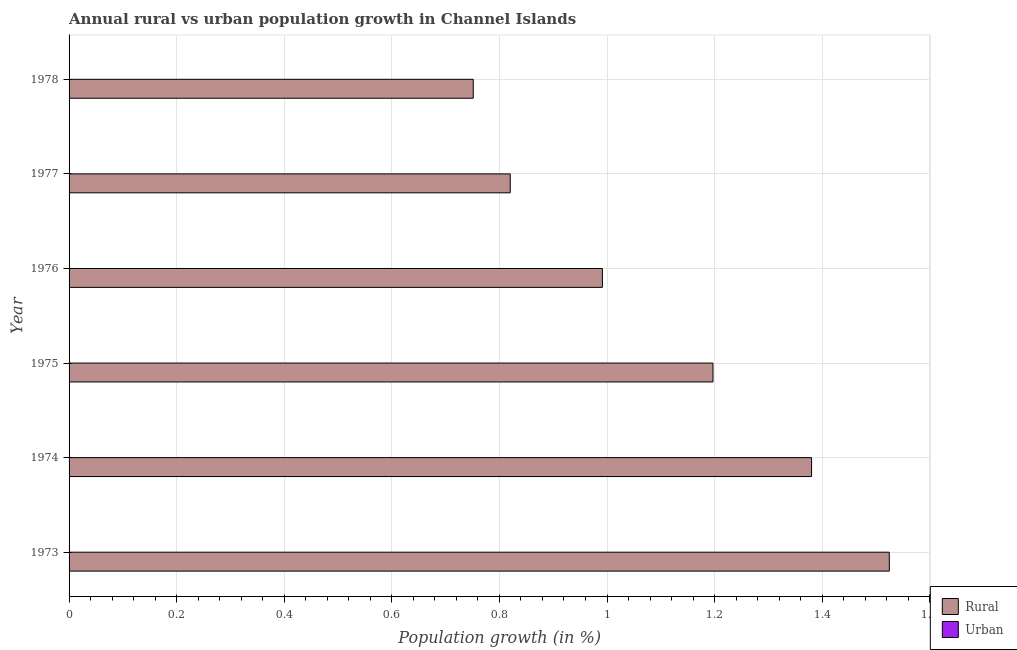Are the number of bars per tick equal to the number of legend labels?
Give a very brief answer. No. Are the number of bars on each tick of the Y-axis equal?
Give a very brief answer. Yes. How many bars are there on the 3rd tick from the top?
Give a very brief answer. 1. What is the label of the 1st group of bars from the top?
Your answer should be compact. 1978. In how many cases, is the number of bars for a given year not equal to the number of legend labels?
Ensure brevity in your answer.  6. What is the rural population growth in 1977?
Provide a succinct answer. 0.82. Across all years, what is the maximum rural population growth?
Provide a succinct answer. 1.52. Across all years, what is the minimum rural population growth?
Provide a succinct answer. 0.75. In which year was the rural population growth maximum?
Your answer should be compact. 1973. What is the total rural population growth in the graph?
Your response must be concise. 6.66. What is the difference between the rural population growth in 1975 and that in 1977?
Ensure brevity in your answer.  0.38. What is the difference between the rural population growth in 1974 and the urban population growth in 1976?
Offer a very short reply. 1.38. What is the average rural population growth per year?
Give a very brief answer. 1.11. In how many years, is the rural population growth greater than 0.9600000000000001 %?
Ensure brevity in your answer.  4. Is the rural population growth in 1975 less than that in 1978?
Offer a terse response. No. What is the difference between the highest and the second highest rural population growth?
Offer a very short reply. 0.14. Are all the bars in the graph horizontal?
Ensure brevity in your answer.  Yes. How many years are there in the graph?
Offer a terse response. 6. Are the values on the major ticks of X-axis written in scientific E-notation?
Ensure brevity in your answer.  No. Does the graph contain grids?
Make the answer very short. Yes. Where does the legend appear in the graph?
Provide a succinct answer. Bottom right. What is the title of the graph?
Keep it short and to the point. Annual rural vs urban population growth in Channel Islands. Does "Foreign liabilities" appear as one of the legend labels in the graph?
Your answer should be compact. No. What is the label or title of the X-axis?
Make the answer very short. Population growth (in %). What is the Population growth (in %) in Rural in 1973?
Your answer should be compact. 1.52. What is the Population growth (in %) in Rural in 1974?
Give a very brief answer. 1.38. What is the Population growth (in %) in Rural in 1975?
Offer a very short reply. 1.2. What is the Population growth (in %) of Urban  in 1975?
Give a very brief answer. 0. What is the Population growth (in %) in Rural in 1976?
Your answer should be very brief. 0.99. What is the Population growth (in %) of Urban  in 1976?
Provide a succinct answer. 0. What is the Population growth (in %) in Rural in 1977?
Provide a short and direct response. 0.82. What is the Population growth (in %) of Rural in 1978?
Offer a terse response. 0.75. Across all years, what is the maximum Population growth (in %) of Rural?
Your answer should be compact. 1.52. Across all years, what is the minimum Population growth (in %) in Rural?
Your answer should be compact. 0.75. What is the total Population growth (in %) of Rural in the graph?
Your answer should be compact. 6.66. What is the difference between the Population growth (in %) of Rural in 1973 and that in 1974?
Provide a short and direct response. 0.14. What is the difference between the Population growth (in %) in Rural in 1973 and that in 1975?
Your answer should be very brief. 0.33. What is the difference between the Population growth (in %) of Rural in 1973 and that in 1976?
Offer a very short reply. 0.53. What is the difference between the Population growth (in %) in Rural in 1973 and that in 1977?
Your answer should be compact. 0.7. What is the difference between the Population growth (in %) in Rural in 1973 and that in 1978?
Offer a terse response. 0.77. What is the difference between the Population growth (in %) of Rural in 1974 and that in 1975?
Your answer should be compact. 0.18. What is the difference between the Population growth (in %) of Rural in 1974 and that in 1976?
Make the answer very short. 0.39. What is the difference between the Population growth (in %) in Rural in 1974 and that in 1977?
Give a very brief answer. 0.56. What is the difference between the Population growth (in %) in Rural in 1974 and that in 1978?
Give a very brief answer. 0.63. What is the difference between the Population growth (in %) in Rural in 1975 and that in 1976?
Your answer should be compact. 0.21. What is the difference between the Population growth (in %) of Rural in 1975 and that in 1977?
Offer a very short reply. 0.38. What is the difference between the Population growth (in %) of Rural in 1975 and that in 1978?
Keep it short and to the point. 0.45. What is the difference between the Population growth (in %) of Rural in 1976 and that in 1977?
Give a very brief answer. 0.17. What is the difference between the Population growth (in %) of Rural in 1976 and that in 1978?
Give a very brief answer. 0.24. What is the difference between the Population growth (in %) in Rural in 1977 and that in 1978?
Make the answer very short. 0.07. What is the average Population growth (in %) in Rural per year?
Provide a succinct answer. 1.11. What is the ratio of the Population growth (in %) in Rural in 1973 to that in 1974?
Ensure brevity in your answer.  1.1. What is the ratio of the Population growth (in %) of Rural in 1973 to that in 1975?
Your answer should be very brief. 1.27. What is the ratio of the Population growth (in %) in Rural in 1973 to that in 1976?
Your answer should be very brief. 1.54. What is the ratio of the Population growth (in %) in Rural in 1973 to that in 1977?
Ensure brevity in your answer.  1.86. What is the ratio of the Population growth (in %) of Rural in 1973 to that in 1978?
Your answer should be compact. 2.03. What is the ratio of the Population growth (in %) of Rural in 1974 to that in 1975?
Keep it short and to the point. 1.15. What is the ratio of the Population growth (in %) in Rural in 1974 to that in 1976?
Keep it short and to the point. 1.39. What is the ratio of the Population growth (in %) of Rural in 1974 to that in 1977?
Offer a very short reply. 1.68. What is the ratio of the Population growth (in %) in Rural in 1974 to that in 1978?
Keep it short and to the point. 1.84. What is the ratio of the Population growth (in %) in Rural in 1975 to that in 1976?
Your answer should be compact. 1.21. What is the ratio of the Population growth (in %) of Rural in 1975 to that in 1977?
Your answer should be very brief. 1.46. What is the ratio of the Population growth (in %) in Rural in 1975 to that in 1978?
Provide a short and direct response. 1.59. What is the ratio of the Population growth (in %) in Rural in 1976 to that in 1977?
Offer a very short reply. 1.21. What is the ratio of the Population growth (in %) in Rural in 1976 to that in 1978?
Provide a short and direct response. 1.32. What is the ratio of the Population growth (in %) of Rural in 1977 to that in 1978?
Give a very brief answer. 1.09. What is the difference between the highest and the second highest Population growth (in %) of Rural?
Your answer should be compact. 0.14. What is the difference between the highest and the lowest Population growth (in %) in Rural?
Offer a very short reply. 0.77. 